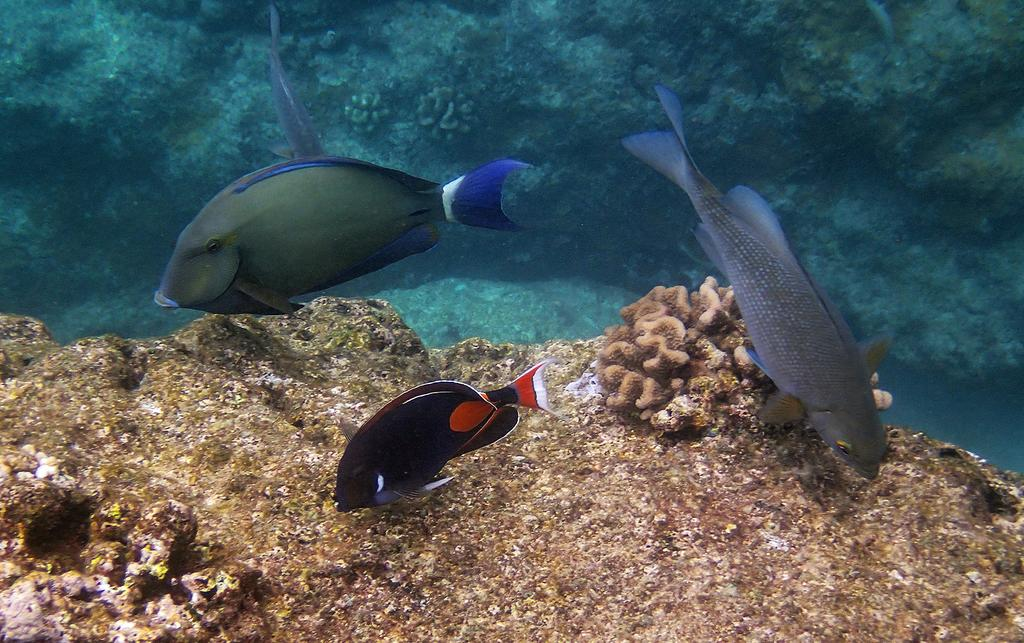How many fishes can be seen in the image? There are three fishes in the image. What else is present in the image besides the fishes? There are sea plants in the image. Where is the beggar sitting on the sofa in the image? There is no beggar or sofa present in the image; it features three fishes and sea plants. What type of sand can be seen in the image? There is no sand present in the image; it features three fishes and sea plants. 